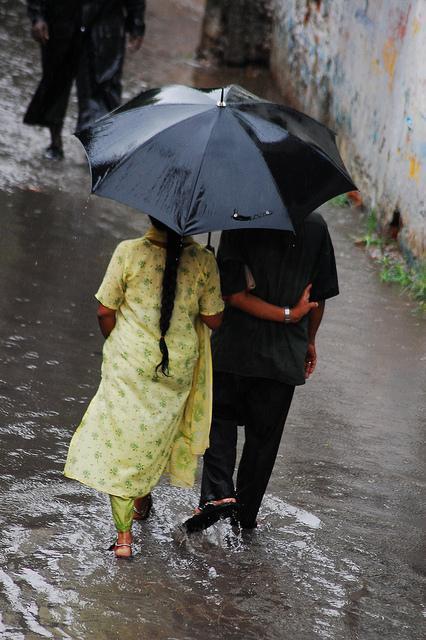How many people can you see?
Give a very brief answer. 3. How many chairs can be seen in the mirror's reflection?
Give a very brief answer. 0. 